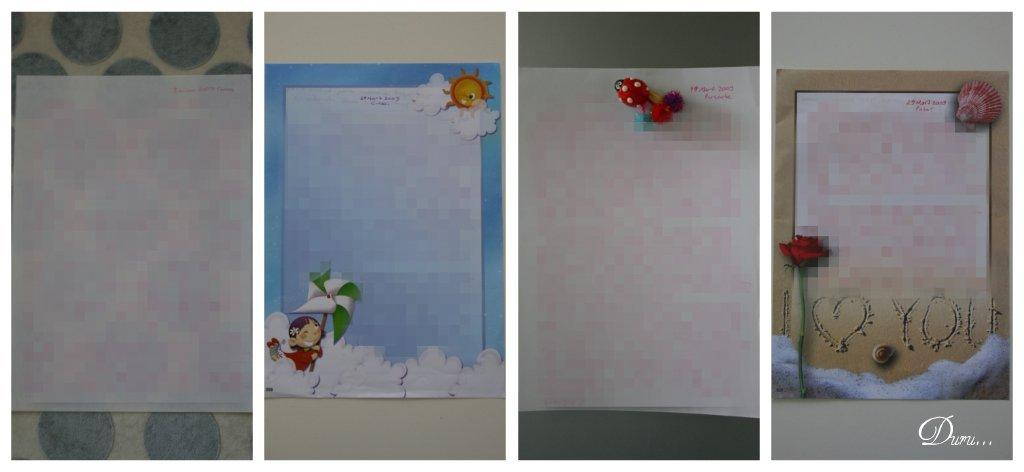How many greeting cards are visible in the image? There are four greeting cards in the image. What has been done to the greeting cards? The greeting cards have been edited. How are the edited greeting cards presented in the image? The edited greeting cards have been combined into a collage. What color is the line that the visitor drew on the greeting card? There is no line or visitor mentioned in the image, so it is not possible to answer that question. 